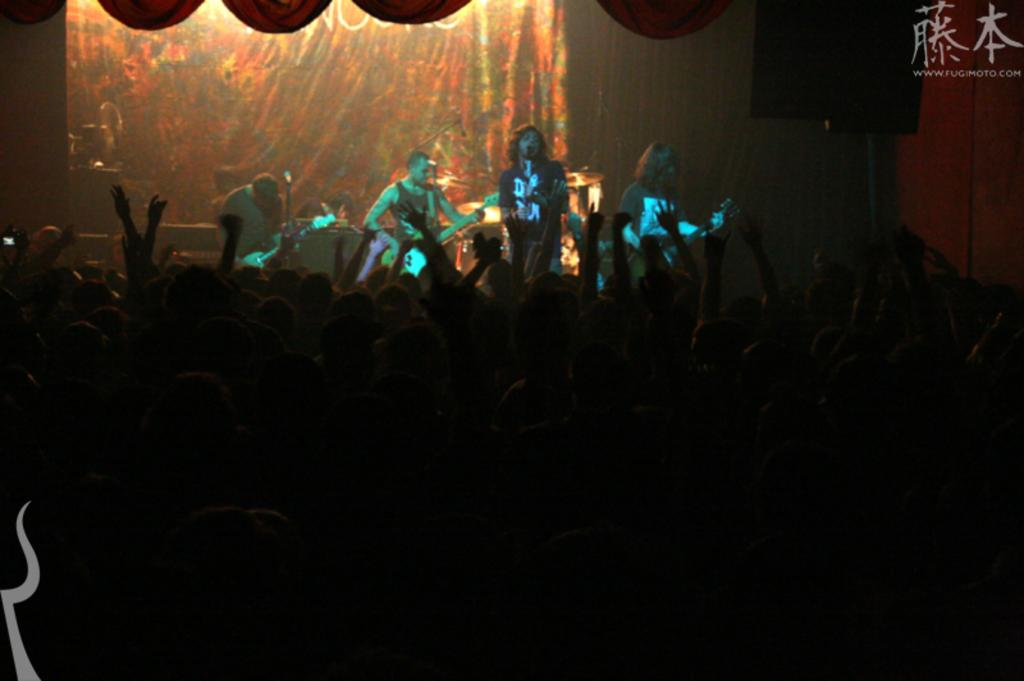What is the main subject of the image? The main subject of the image is a group of people. What are some of the people in the image doing? Some of the people in the image are playing musical instruments. What else can be seen in the image? There is a curtain visible in the image. What type of joke can be seen being told in the image? There is no joke being told in the image; it features a group of people with musical instruments and a curtain. 